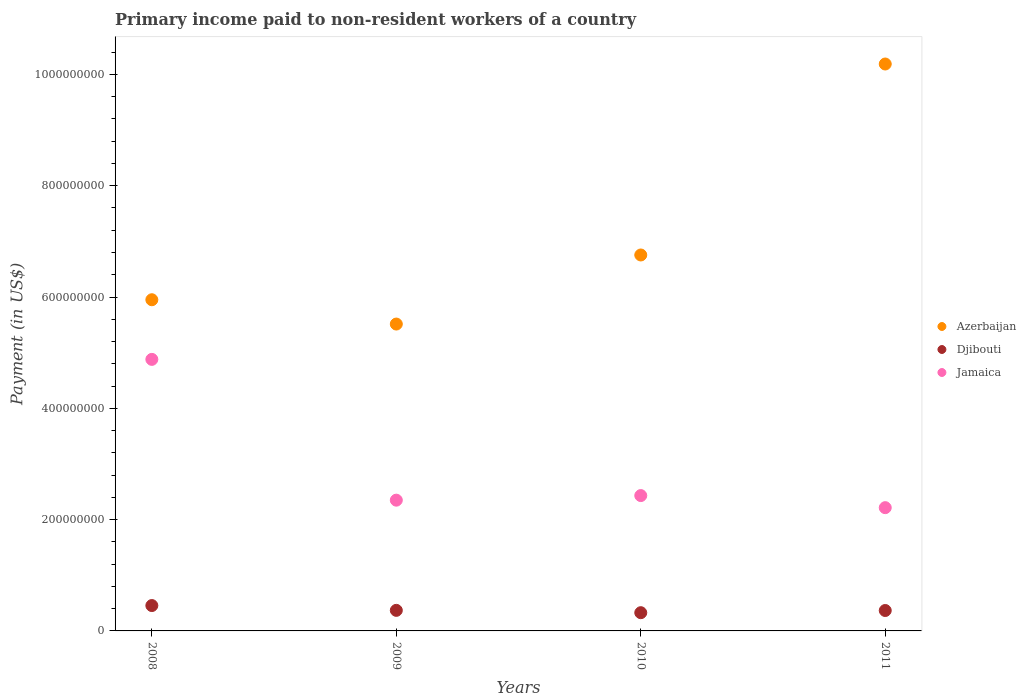Is the number of dotlines equal to the number of legend labels?
Your answer should be compact. Yes. What is the amount paid to workers in Azerbaijan in 2010?
Your answer should be compact. 6.76e+08. Across all years, what is the maximum amount paid to workers in Djibouti?
Make the answer very short. 4.56e+07. Across all years, what is the minimum amount paid to workers in Azerbaijan?
Offer a very short reply. 5.51e+08. What is the total amount paid to workers in Jamaica in the graph?
Make the answer very short. 1.19e+09. What is the difference between the amount paid to workers in Djibouti in 2010 and that in 2011?
Offer a very short reply. -3.93e+06. What is the difference between the amount paid to workers in Azerbaijan in 2011 and the amount paid to workers in Jamaica in 2010?
Ensure brevity in your answer.  7.76e+08. What is the average amount paid to workers in Azerbaijan per year?
Give a very brief answer. 7.10e+08. In the year 2011, what is the difference between the amount paid to workers in Djibouti and amount paid to workers in Azerbaijan?
Keep it short and to the point. -9.82e+08. In how many years, is the amount paid to workers in Azerbaijan greater than 600000000 US$?
Provide a short and direct response. 2. What is the ratio of the amount paid to workers in Jamaica in 2008 to that in 2011?
Keep it short and to the point. 2.2. Is the amount paid to workers in Azerbaijan in 2008 less than that in 2009?
Offer a terse response. No. Is the difference between the amount paid to workers in Djibouti in 2008 and 2011 greater than the difference between the amount paid to workers in Azerbaijan in 2008 and 2011?
Ensure brevity in your answer.  Yes. What is the difference between the highest and the second highest amount paid to workers in Azerbaijan?
Give a very brief answer. 3.43e+08. What is the difference between the highest and the lowest amount paid to workers in Azerbaijan?
Keep it short and to the point. 4.67e+08. Is the sum of the amount paid to workers in Jamaica in 2009 and 2010 greater than the maximum amount paid to workers in Azerbaijan across all years?
Offer a very short reply. No. Is it the case that in every year, the sum of the amount paid to workers in Jamaica and amount paid to workers in Azerbaijan  is greater than the amount paid to workers in Djibouti?
Give a very brief answer. Yes. How many dotlines are there?
Your answer should be compact. 3. How many legend labels are there?
Keep it short and to the point. 3. What is the title of the graph?
Keep it short and to the point. Primary income paid to non-resident workers of a country. Does "West Bank and Gaza" appear as one of the legend labels in the graph?
Ensure brevity in your answer.  No. What is the label or title of the X-axis?
Give a very brief answer. Years. What is the label or title of the Y-axis?
Keep it short and to the point. Payment (in US$). What is the Payment (in US$) of Azerbaijan in 2008?
Provide a short and direct response. 5.95e+08. What is the Payment (in US$) in Djibouti in 2008?
Your answer should be compact. 4.56e+07. What is the Payment (in US$) in Jamaica in 2008?
Make the answer very short. 4.88e+08. What is the Payment (in US$) of Azerbaijan in 2009?
Keep it short and to the point. 5.51e+08. What is the Payment (in US$) in Djibouti in 2009?
Provide a short and direct response. 3.70e+07. What is the Payment (in US$) in Jamaica in 2009?
Keep it short and to the point. 2.35e+08. What is the Payment (in US$) in Azerbaijan in 2010?
Offer a very short reply. 6.76e+08. What is the Payment (in US$) of Djibouti in 2010?
Offer a very short reply. 3.28e+07. What is the Payment (in US$) of Jamaica in 2010?
Give a very brief answer. 2.43e+08. What is the Payment (in US$) of Azerbaijan in 2011?
Give a very brief answer. 1.02e+09. What is the Payment (in US$) in Djibouti in 2011?
Offer a terse response. 3.67e+07. What is the Payment (in US$) in Jamaica in 2011?
Offer a terse response. 2.21e+08. Across all years, what is the maximum Payment (in US$) in Azerbaijan?
Your answer should be compact. 1.02e+09. Across all years, what is the maximum Payment (in US$) of Djibouti?
Provide a short and direct response. 4.56e+07. Across all years, what is the maximum Payment (in US$) in Jamaica?
Offer a terse response. 4.88e+08. Across all years, what is the minimum Payment (in US$) in Azerbaijan?
Keep it short and to the point. 5.51e+08. Across all years, what is the minimum Payment (in US$) in Djibouti?
Give a very brief answer. 3.28e+07. Across all years, what is the minimum Payment (in US$) of Jamaica?
Provide a short and direct response. 2.21e+08. What is the total Payment (in US$) in Azerbaijan in the graph?
Your answer should be compact. 2.84e+09. What is the total Payment (in US$) of Djibouti in the graph?
Offer a very short reply. 1.52e+08. What is the total Payment (in US$) of Jamaica in the graph?
Offer a terse response. 1.19e+09. What is the difference between the Payment (in US$) of Azerbaijan in 2008 and that in 2009?
Offer a very short reply. 4.37e+07. What is the difference between the Payment (in US$) of Djibouti in 2008 and that in 2009?
Provide a succinct answer. 8.63e+06. What is the difference between the Payment (in US$) in Jamaica in 2008 and that in 2009?
Keep it short and to the point. 2.53e+08. What is the difference between the Payment (in US$) in Azerbaijan in 2008 and that in 2010?
Give a very brief answer. -8.04e+07. What is the difference between the Payment (in US$) in Djibouti in 2008 and that in 2010?
Ensure brevity in your answer.  1.28e+07. What is the difference between the Payment (in US$) in Jamaica in 2008 and that in 2010?
Provide a succinct answer. 2.45e+08. What is the difference between the Payment (in US$) of Azerbaijan in 2008 and that in 2011?
Provide a succinct answer. -4.24e+08. What is the difference between the Payment (in US$) of Djibouti in 2008 and that in 2011?
Your answer should be very brief. 8.90e+06. What is the difference between the Payment (in US$) in Jamaica in 2008 and that in 2011?
Provide a succinct answer. 2.66e+08. What is the difference between the Payment (in US$) in Azerbaijan in 2009 and that in 2010?
Offer a very short reply. -1.24e+08. What is the difference between the Payment (in US$) of Djibouti in 2009 and that in 2010?
Your answer should be very brief. 4.20e+06. What is the difference between the Payment (in US$) in Jamaica in 2009 and that in 2010?
Offer a very short reply. -8.24e+06. What is the difference between the Payment (in US$) in Azerbaijan in 2009 and that in 2011?
Provide a short and direct response. -4.67e+08. What is the difference between the Payment (in US$) of Djibouti in 2009 and that in 2011?
Your answer should be very brief. 2.76e+05. What is the difference between the Payment (in US$) in Jamaica in 2009 and that in 2011?
Offer a terse response. 1.35e+07. What is the difference between the Payment (in US$) of Azerbaijan in 2010 and that in 2011?
Offer a terse response. -3.43e+08. What is the difference between the Payment (in US$) of Djibouti in 2010 and that in 2011?
Your answer should be compact. -3.93e+06. What is the difference between the Payment (in US$) in Jamaica in 2010 and that in 2011?
Ensure brevity in your answer.  2.17e+07. What is the difference between the Payment (in US$) in Azerbaijan in 2008 and the Payment (in US$) in Djibouti in 2009?
Your answer should be very brief. 5.58e+08. What is the difference between the Payment (in US$) of Azerbaijan in 2008 and the Payment (in US$) of Jamaica in 2009?
Make the answer very short. 3.60e+08. What is the difference between the Payment (in US$) of Djibouti in 2008 and the Payment (in US$) of Jamaica in 2009?
Make the answer very short. -1.89e+08. What is the difference between the Payment (in US$) of Azerbaijan in 2008 and the Payment (in US$) of Djibouti in 2010?
Provide a short and direct response. 5.62e+08. What is the difference between the Payment (in US$) of Azerbaijan in 2008 and the Payment (in US$) of Jamaica in 2010?
Your answer should be compact. 3.52e+08. What is the difference between the Payment (in US$) in Djibouti in 2008 and the Payment (in US$) in Jamaica in 2010?
Your answer should be compact. -1.98e+08. What is the difference between the Payment (in US$) in Azerbaijan in 2008 and the Payment (in US$) in Djibouti in 2011?
Give a very brief answer. 5.58e+08. What is the difference between the Payment (in US$) in Azerbaijan in 2008 and the Payment (in US$) in Jamaica in 2011?
Your answer should be very brief. 3.74e+08. What is the difference between the Payment (in US$) of Djibouti in 2008 and the Payment (in US$) of Jamaica in 2011?
Your answer should be compact. -1.76e+08. What is the difference between the Payment (in US$) in Azerbaijan in 2009 and the Payment (in US$) in Djibouti in 2010?
Give a very brief answer. 5.19e+08. What is the difference between the Payment (in US$) in Azerbaijan in 2009 and the Payment (in US$) in Jamaica in 2010?
Give a very brief answer. 3.08e+08. What is the difference between the Payment (in US$) of Djibouti in 2009 and the Payment (in US$) of Jamaica in 2010?
Keep it short and to the point. -2.06e+08. What is the difference between the Payment (in US$) of Azerbaijan in 2009 and the Payment (in US$) of Djibouti in 2011?
Keep it short and to the point. 5.15e+08. What is the difference between the Payment (in US$) of Azerbaijan in 2009 and the Payment (in US$) of Jamaica in 2011?
Your answer should be very brief. 3.30e+08. What is the difference between the Payment (in US$) of Djibouti in 2009 and the Payment (in US$) of Jamaica in 2011?
Provide a succinct answer. -1.85e+08. What is the difference between the Payment (in US$) of Azerbaijan in 2010 and the Payment (in US$) of Djibouti in 2011?
Make the answer very short. 6.39e+08. What is the difference between the Payment (in US$) in Azerbaijan in 2010 and the Payment (in US$) in Jamaica in 2011?
Your response must be concise. 4.54e+08. What is the difference between the Payment (in US$) in Djibouti in 2010 and the Payment (in US$) in Jamaica in 2011?
Provide a short and direct response. -1.89e+08. What is the average Payment (in US$) in Azerbaijan per year?
Provide a short and direct response. 7.10e+08. What is the average Payment (in US$) in Djibouti per year?
Your answer should be compact. 3.80e+07. What is the average Payment (in US$) of Jamaica per year?
Your response must be concise. 2.97e+08. In the year 2008, what is the difference between the Payment (in US$) in Azerbaijan and Payment (in US$) in Djibouti?
Provide a succinct answer. 5.50e+08. In the year 2008, what is the difference between the Payment (in US$) of Azerbaijan and Payment (in US$) of Jamaica?
Your answer should be compact. 1.07e+08. In the year 2008, what is the difference between the Payment (in US$) of Djibouti and Payment (in US$) of Jamaica?
Give a very brief answer. -4.42e+08. In the year 2009, what is the difference between the Payment (in US$) in Azerbaijan and Payment (in US$) in Djibouti?
Offer a terse response. 5.14e+08. In the year 2009, what is the difference between the Payment (in US$) in Azerbaijan and Payment (in US$) in Jamaica?
Your answer should be compact. 3.16e+08. In the year 2009, what is the difference between the Payment (in US$) of Djibouti and Payment (in US$) of Jamaica?
Provide a succinct answer. -1.98e+08. In the year 2010, what is the difference between the Payment (in US$) in Azerbaijan and Payment (in US$) in Djibouti?
Your response must be concise. 6.43e+08. In the year 2010, what is the difference between the Payment (in US$) in Azerbaijan and Payment (in US$) in Jamaica?
Your answer should be very brief. 4.32e+08. In the year 2010, what is the difference between the Payment (in US$) of Djibouti and Payment (in US$) of Jamaica?
Offer a very short reply. -2.10e+08. In the year 2011, what is the difference between the Payment (in US$) of Azerbaijan and Payment (in US$) of Djibouti?
Ensure brevity in your answer.  9.82e+08. In the year 2011, what is the difference between the Payment (in US$) in Azerbaijan and Payment (in US$) in Jamaica?
Keep it short and to the point. 7.97e+08. In the year 2011, what is the difference between the Payment (in US$) of Djibouti and Payment (in US$) of Jamaica?
Keep it short and to the point. -1.85e+08. What is the ratio of the Payment (in US$) of Azerbaijan in 2008 to that in 2009?
Keep it short and to the point. 1.08. What is the ratio of the Payment (in US$) in Djibouti in 2008 to that in 2009?
Give a very brief answer. 1.23. What is the ratio of the Payment (in US$) in Jamaica in 2008 to that in 2009?
Offer a very short reply. 2.08. What is the ratio of the Payment (in US$) in Azerbaijan in 2008 to that in 2010?
Your answer should be very brief. 0.88. What is the ratio of the Payment (in US$) in Djibouti in 2008 to that in 2010?
Make the answer very short. 1.39. What is the ratio of the Payment (in US$) of Jamaica in 2008 to that in 2010?
Provide a short and direct response. 2.01. What is the ratio of the Payment (in US$) in Azerbaijan in 2008 to that in 2011?
Your answer should be very brief. 0.58. What is the ratio of the Payment (in US$) of Djibouti in 2008 to that in 2011?
Provide a short and direct response. 1.24. What is the ratio of the Payment (in US$) of Jamaica in 2008 to that in 2011?
Provide a short and direct response. 2.2. What is the ratio of the Payment (in US$) in Azerbaijan in 2009 to that in 2010?
Your answer should be very brief. 0.82. What is the ratio of the Payment (in US$) in Djibouti in 2009 to that in 2010?
Offer a very short reply. 1.13. What is the ratio of the Payment (in US$) in Jamaica in 2009 to that in 2010?
Provide a short and direct response. 0.97. What is the ratio of the Payment (in US$) of Azerbaijan in 2009 to that in 2011?
Keep it short and to the point. 0.54. What is the ratio of the Payment (in US$) in Djibouti in 2009 to that in 2011?
Your answer should be very brief. 1.01. What is the ratio of the Payment (in US$) of Jamaica in 2009 to that in 2011?
Make the answer very short. 1.06. What is the ratio of the Payment (in US$) of Azerbaijan in 2010 to that in 2011?
Make the answer very short. 0.66. What is the ratio of the Payment (in US$) in Djibouti in 2010 to that in 2011?
Your answer should be compact. 0.89. What is the ratio of the Payment (in US$) of Jamaica in 2010 to that in 2011?
Your response must be concise. 1.1. What is the difference between the highest and the second highest Payment (in US$) of Azerbaijan?
Ensure brevity in your answer.  3.43e+08. What is the difference between the highest and the second highest Payment (in US$) in Djibouti?
Make the answer very short. 8.63e+06. What is the difference between the highest and the second highest Payment (in US$) in Jamaica?
Your answer should be very brief. 2.45e+08. What is the difference between the highest and the lowest Payment (in US$) in Azerbaijan?
Keep it short and to the point. 4.67e+08. What is the difference between the highest and the lowest Payment (in US$) in Djibouti?
Your answer should be compact. 1.28e+07. What is the difference between the highest and the lowest Payment (in US$) in Jamaica?
Ensure brevity in your answer.  2.66e+08. 